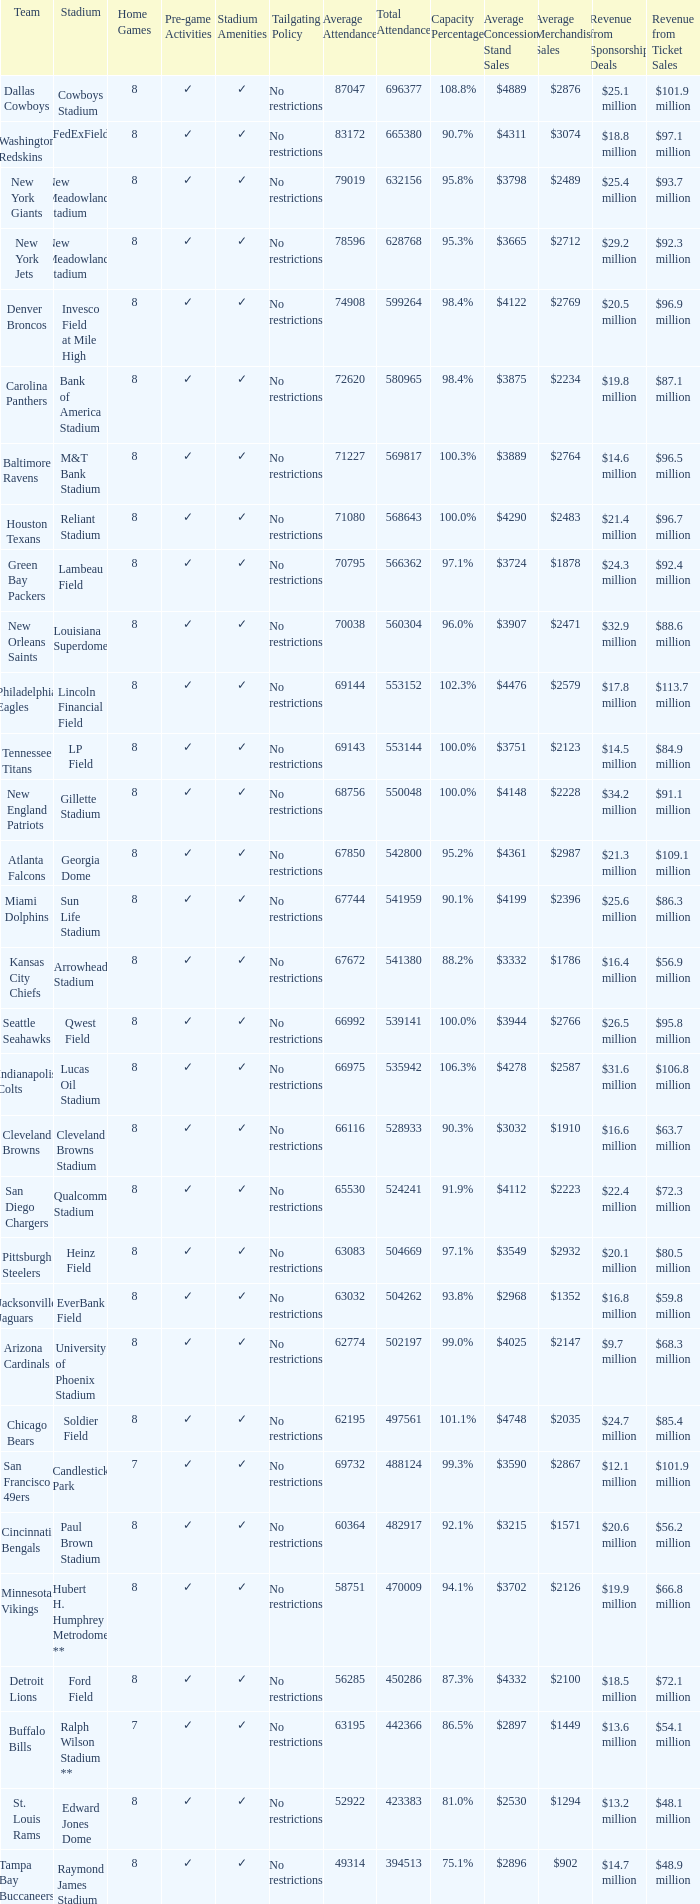What was the overall attendance of the new york giants? 632156.0. 